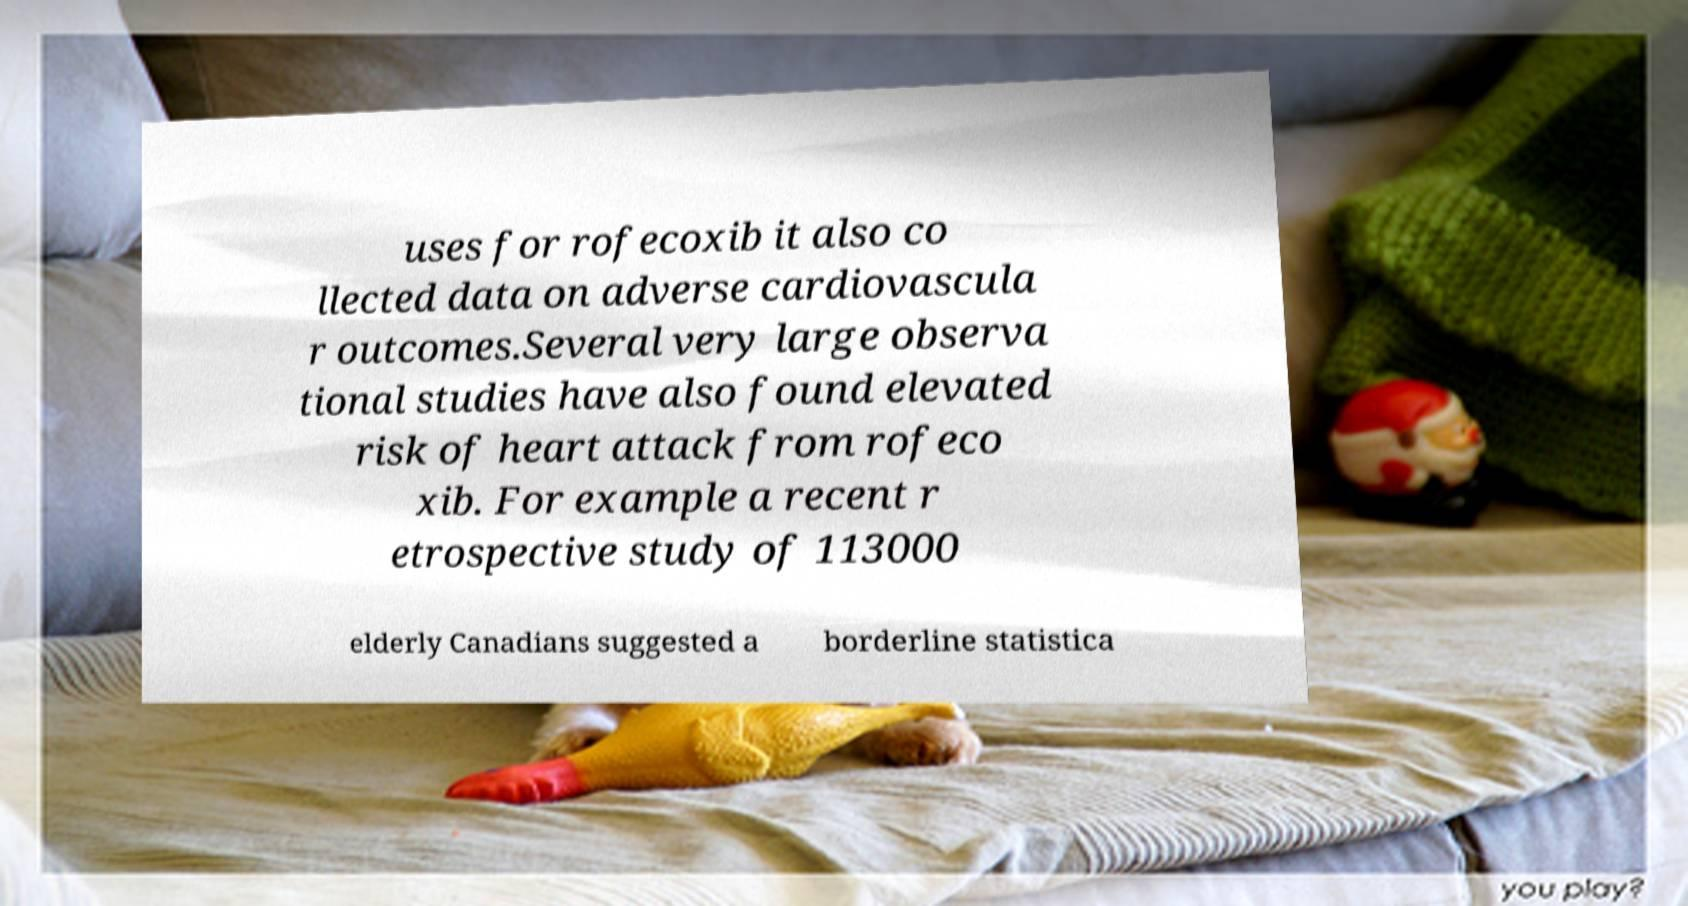Could you assist in decoding the text presented in this image and type it out clearly? uses for rofecoxib it also co llected data on adverse cardiovascula r outcomes.Several very large observa tional studies have also found elevated risk of heart attack from rofeco xib. For example a recent r etrospective study of 113000 elderly Canadians suggested a borderline statistica 